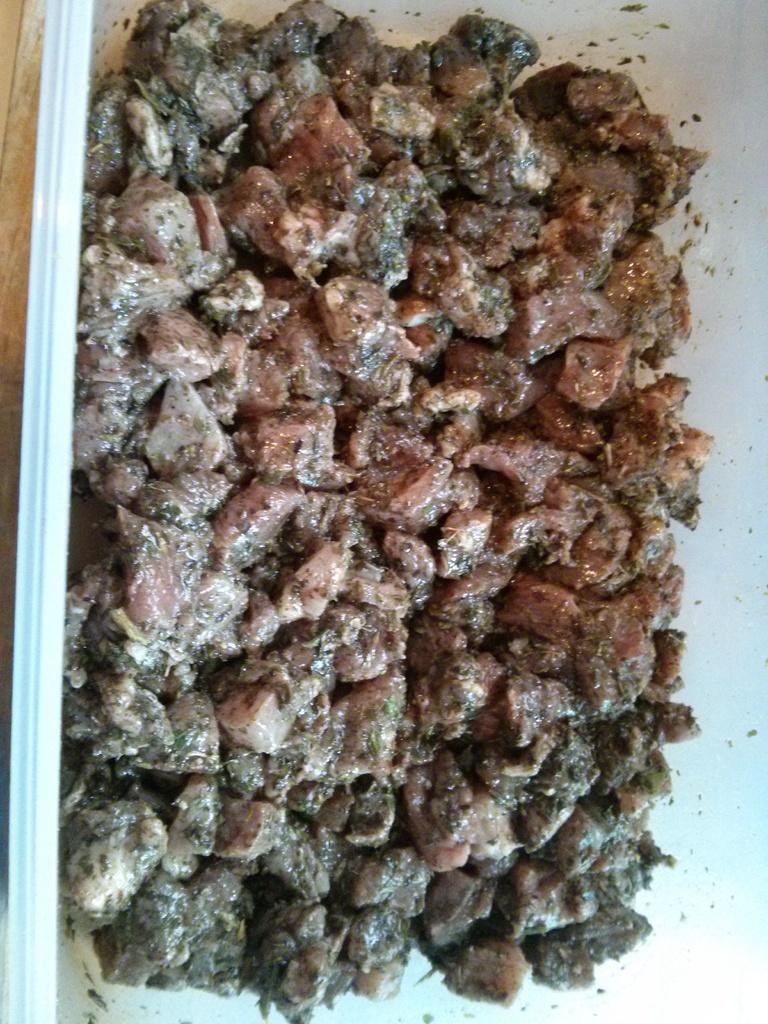What color is the eye of the sugar parent in the image? There is no eye, sugar, or parent present in the image, as no specific facts were provided. 